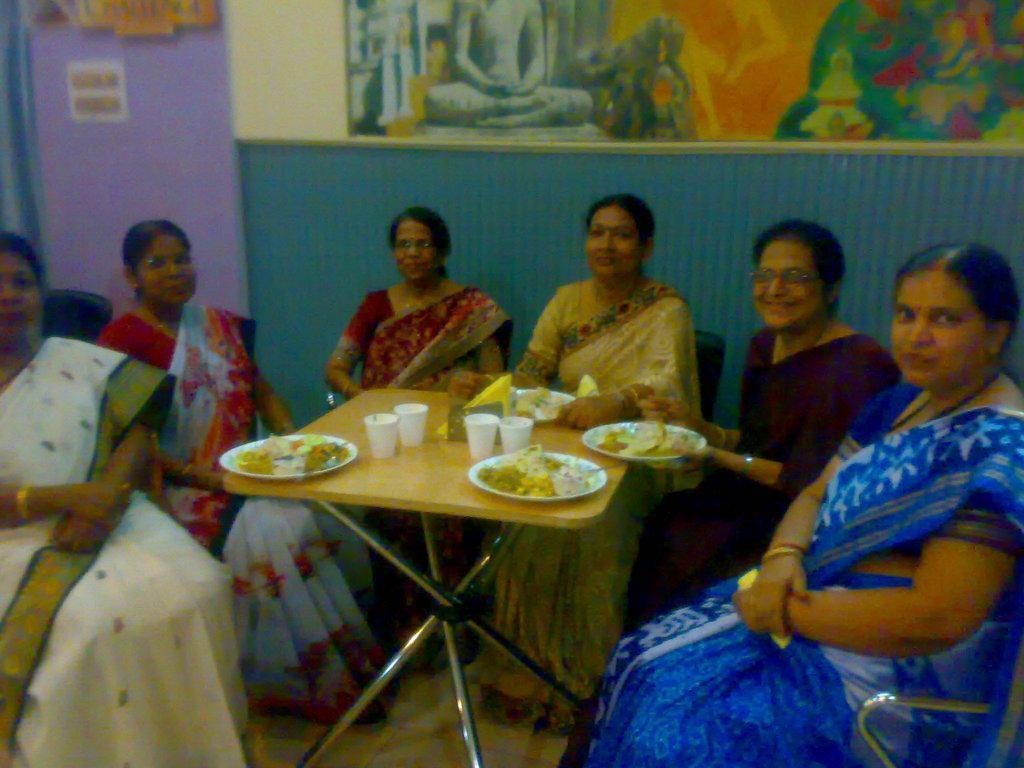Describe this image in one or two sentences. In the middle of the image few women sitting on the chair. In the middle of the image there is a table, On the table there is a table plate and cup and tissue papers. At the top of the image there is a wall, On the wall there is a painting. 